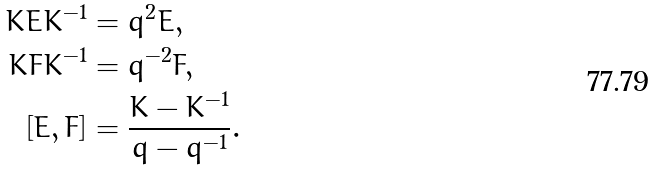Convert formula to latex. <formula><loc_0><loc_0><loc_500><loc_500>K E K ^ { - 1 } & = q ^ { 2 } E , \\ K F K ^ { - 1 } & = q ^ { - 2 } F , \\ [ E , F ] & = \frac { K - K ^ { - 1 } } { q - q ^ { - 1 } } .</formula> 